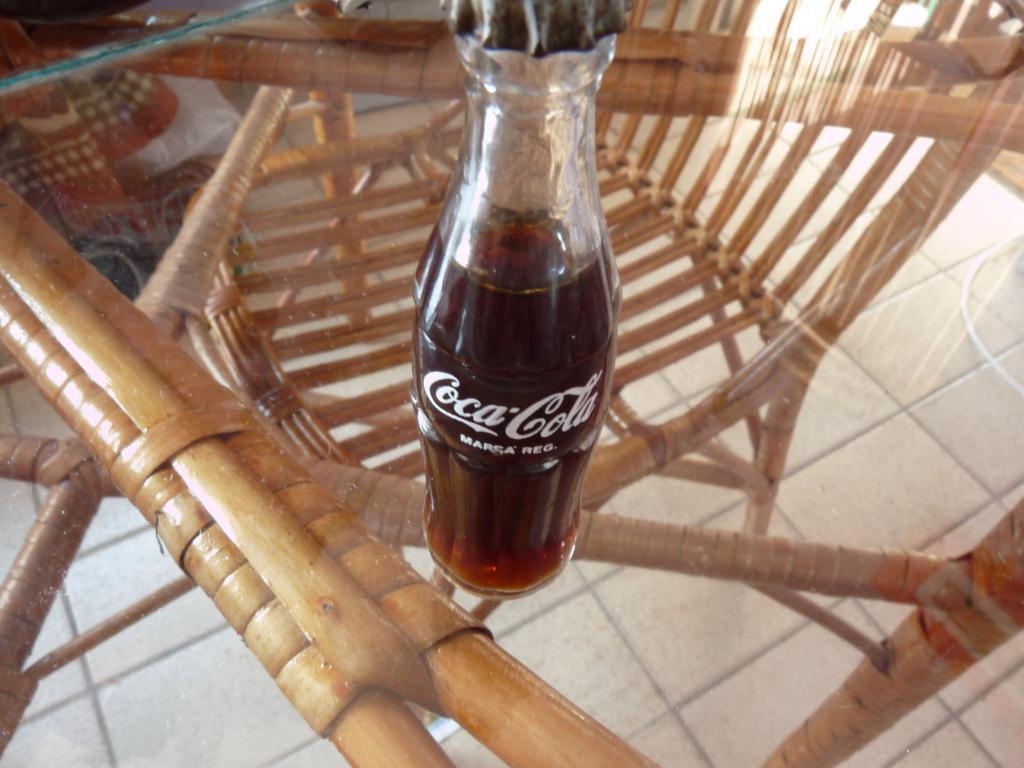Could you give a brief overview of what you see in this image? A coke bottle is on a table. 